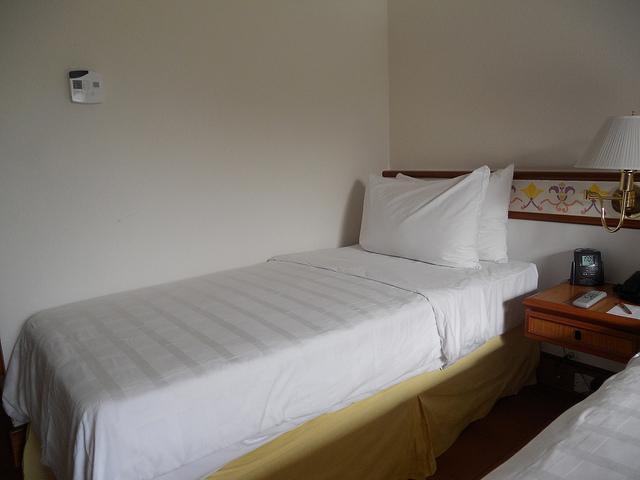How many pillows are on the bed?
Give a very brief answer. 2. How many pillows are there?
Give a very brief answer. 2. How many beds are there?
Give a very brief answer. 2. How many arms does the boy have?
Give a very brief answer. 0. 